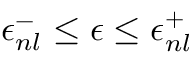Convert formula to latex. <formula><loc_0><loc_0><loc_500><loc_500>\epsilon _ { n l } ^ { - } \leq \epsilon \leq \epsilon _ { n l } ^ { + }</formula> 